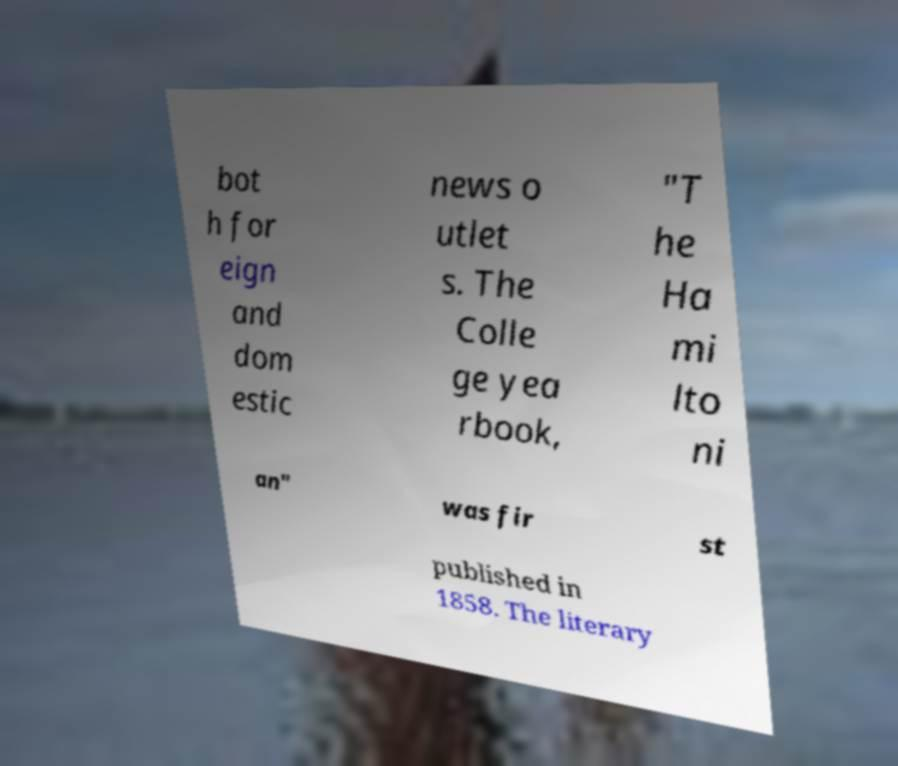Can you read and provide the text displayed in the image?This photo seems to have some interesting text. Can you extract and type it out for me? bot h for eign and dom estic news o utlet s. The Colle ge yea rbook, "T he Ha mi lto ni an" was fir st published in 1858. The literary 